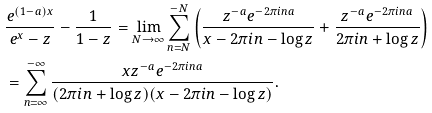<formula> <loc_0><loc_0><loc_500><loc_500>& \frac { e ^ { ( 1 - a ) x } } { e ^ { x } - z } - \frac { 1 } { 1 - z } = \lim _ { N \to \infty } \sum _ { n = N } ^ { - N } \left ( \frac { z ^ { - a } e ^ { - 2 \pi i n a } } { x - 2 \pi i n - \log z } + \frac { z ^ { - a } e ^ { - 2 \pi i n a } } { 2 \pi i n + \log z } \right ) \\ & = \sum _ { n = \infty } ^ { - \infty } \frac { x z ^ { - a } e ^ { - 2 \pi i n a } } { ( 2 \pi i n + \log z ) ( x - 2 \pi i n - \log z ) } .</formula> 